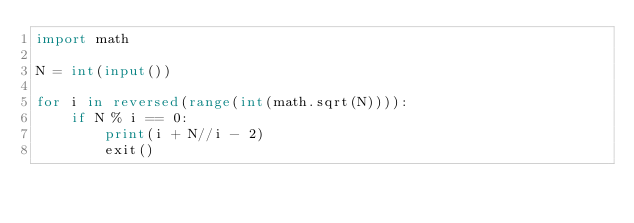Convert code to text. <code><loc_0><loc_0><loc_500><loc_500><_Python_>import math

N = int(input())

for i in reversed(range(int(math.sqrt(N)))):
    if N % i == 0:
        print(i + N//i - 2)
        exit()</code> 